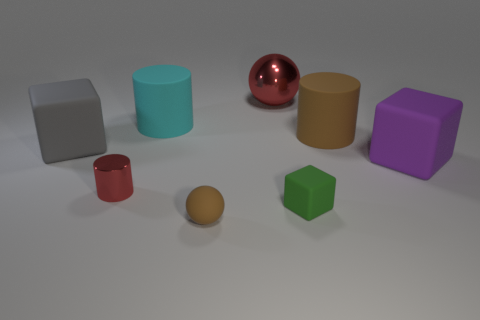What colors are present among the objects, and do they represent something in particular? The objects display a variety of colors including gray, cyan, red, yellow, green, and purple. There doesn't seem to be a specific representation or pattern to the colors; they likely serve to differentiate the objects or for aesthetic purposes. 